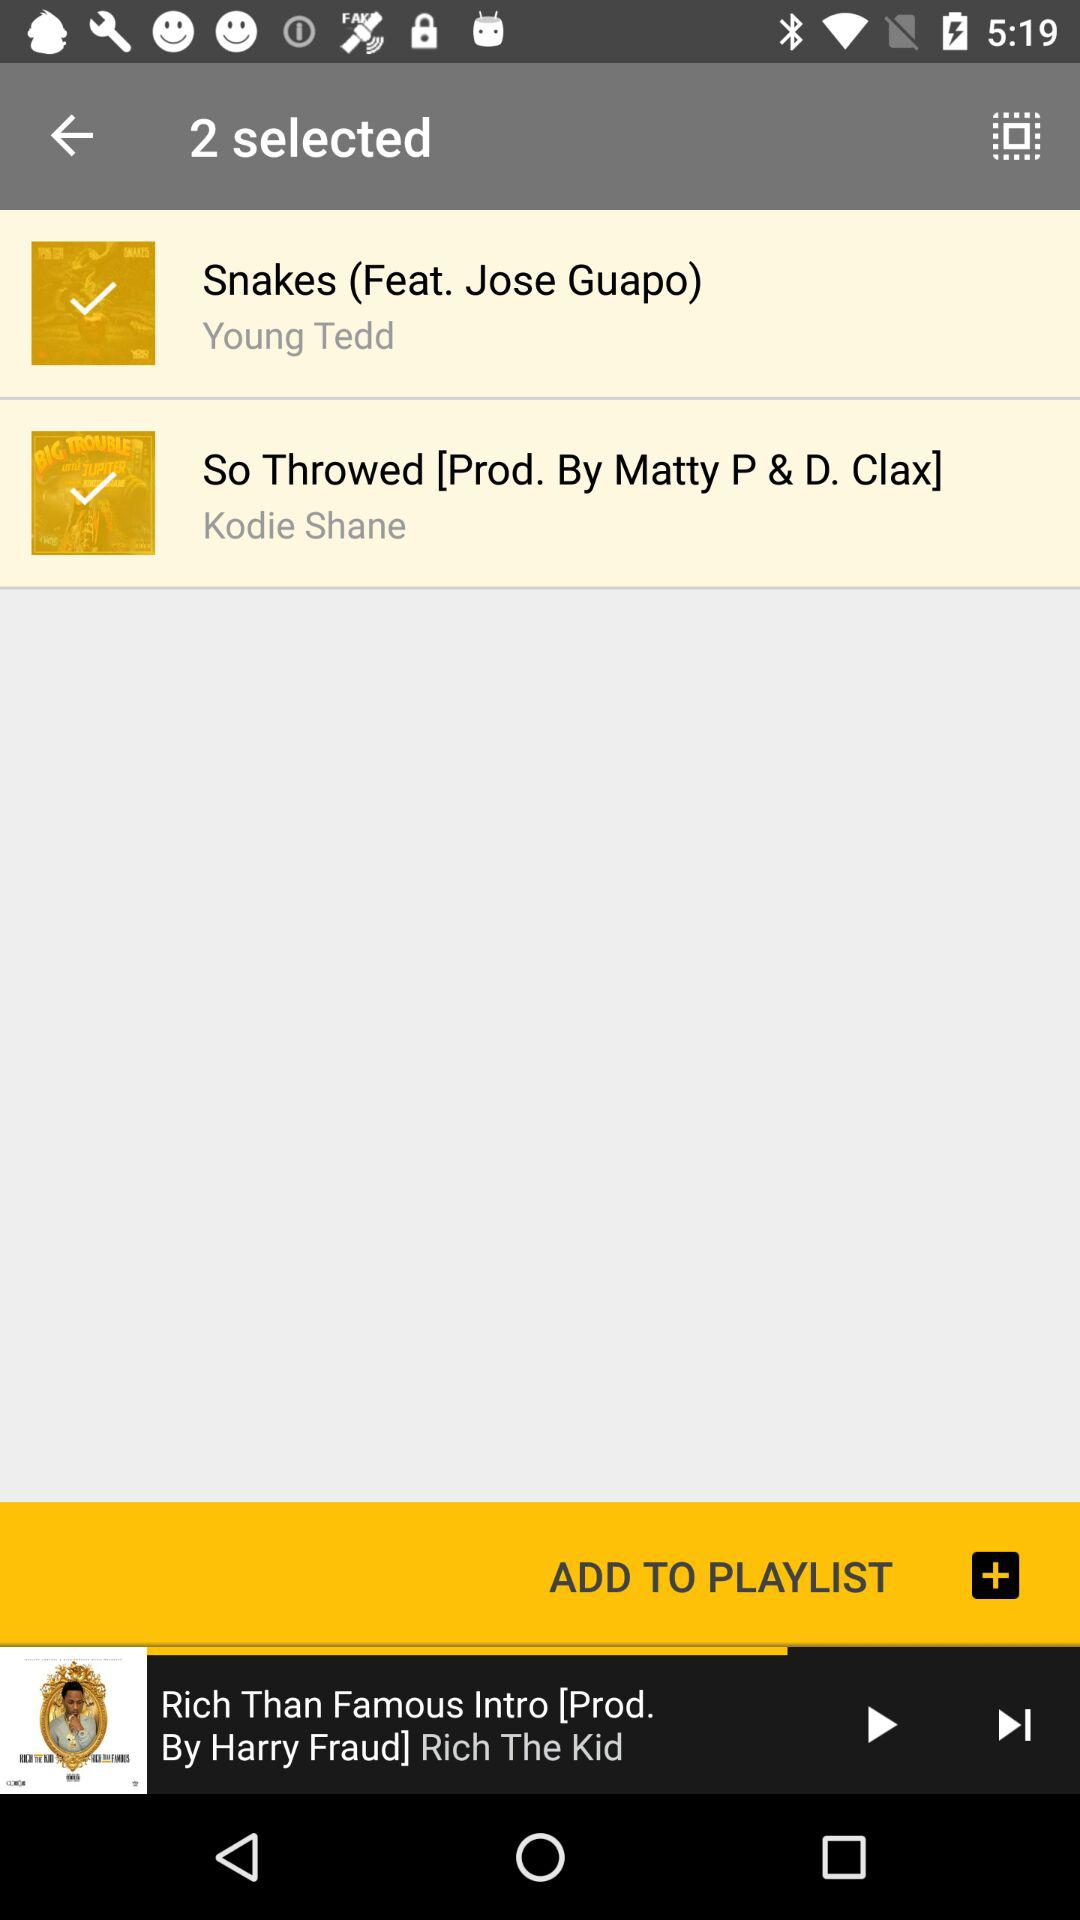Which song was last played? The song that was last played was "Rich Than Famous Intro". 